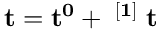Convert formula to latex. <formula><loc_0><loc_0><loc_500><loc_500>t = t ^ { 0 } + \theta ^ { [ 1 ] } \Delta t</formula> 